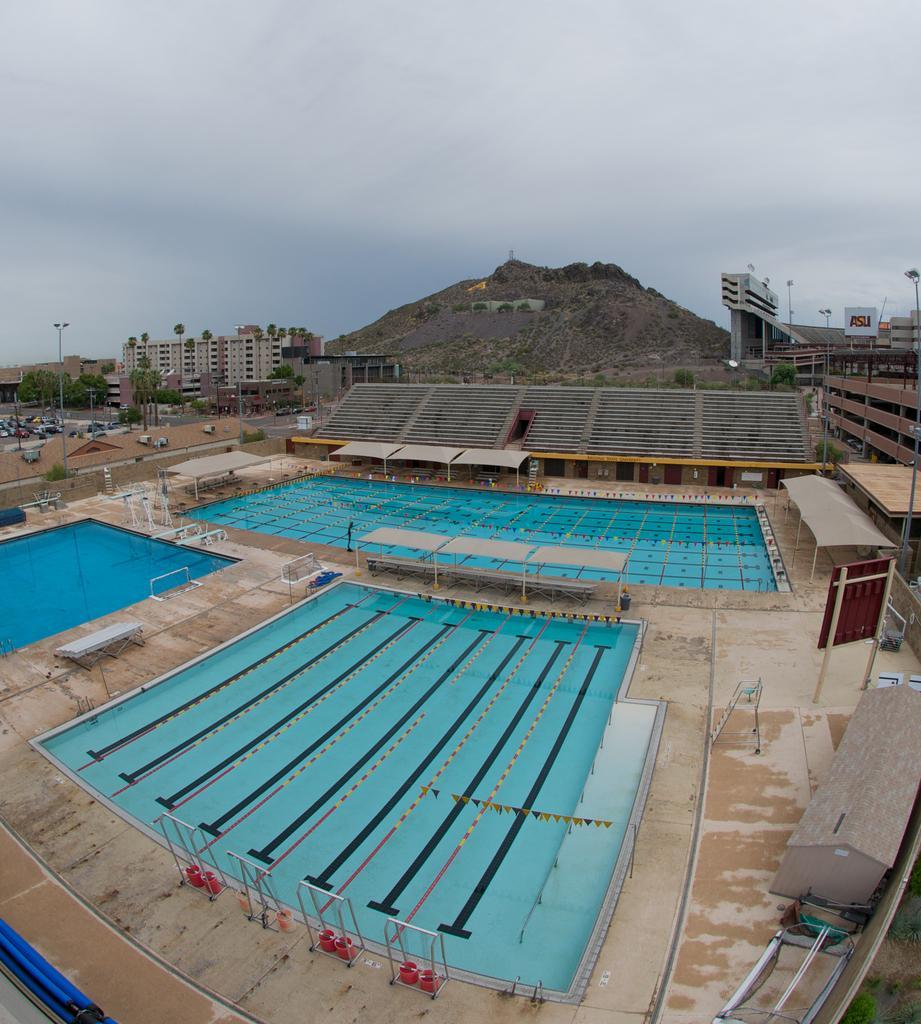Could you give a brief overview of what you see in this image? There are three swimming pools and there are few buildings,vehicles and a mountain in the background. 